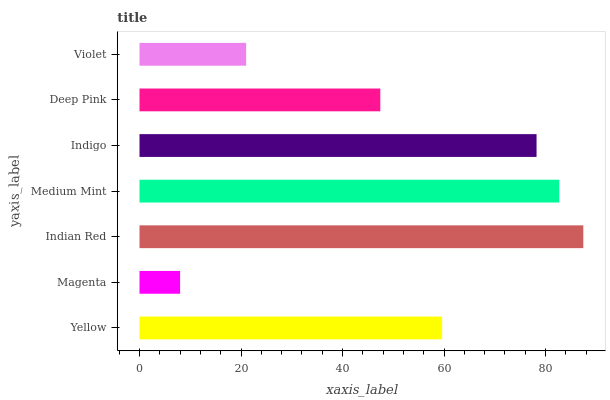Is Magenta the minimum?
Answer yes or no. Yes. Is Indian Red the maximum?
Answer yes or no. Yes. Is Indian Red the minimum?
Answer yes or no. No. Is Magenta the maximum?
Answer yes or no. No. Is Indian Red greater than Magenta?
Answer yes or no. Yes. Is Magenta less than Indian Red?
Answer yes or no. Yes. Is Magenta greater than Indian Red?
Answer yes or no. No. Is Indian Red less than Magenta?
Answer yes or no. No. Is Yellow the high median?
Answer yes or no. Yes. Is Yellow the low median?
Answer yes or no. Yes. Is Indian Red the high median?
Answer yes or no. No. Is Indigo the low median?
Answer yes or no. No. 